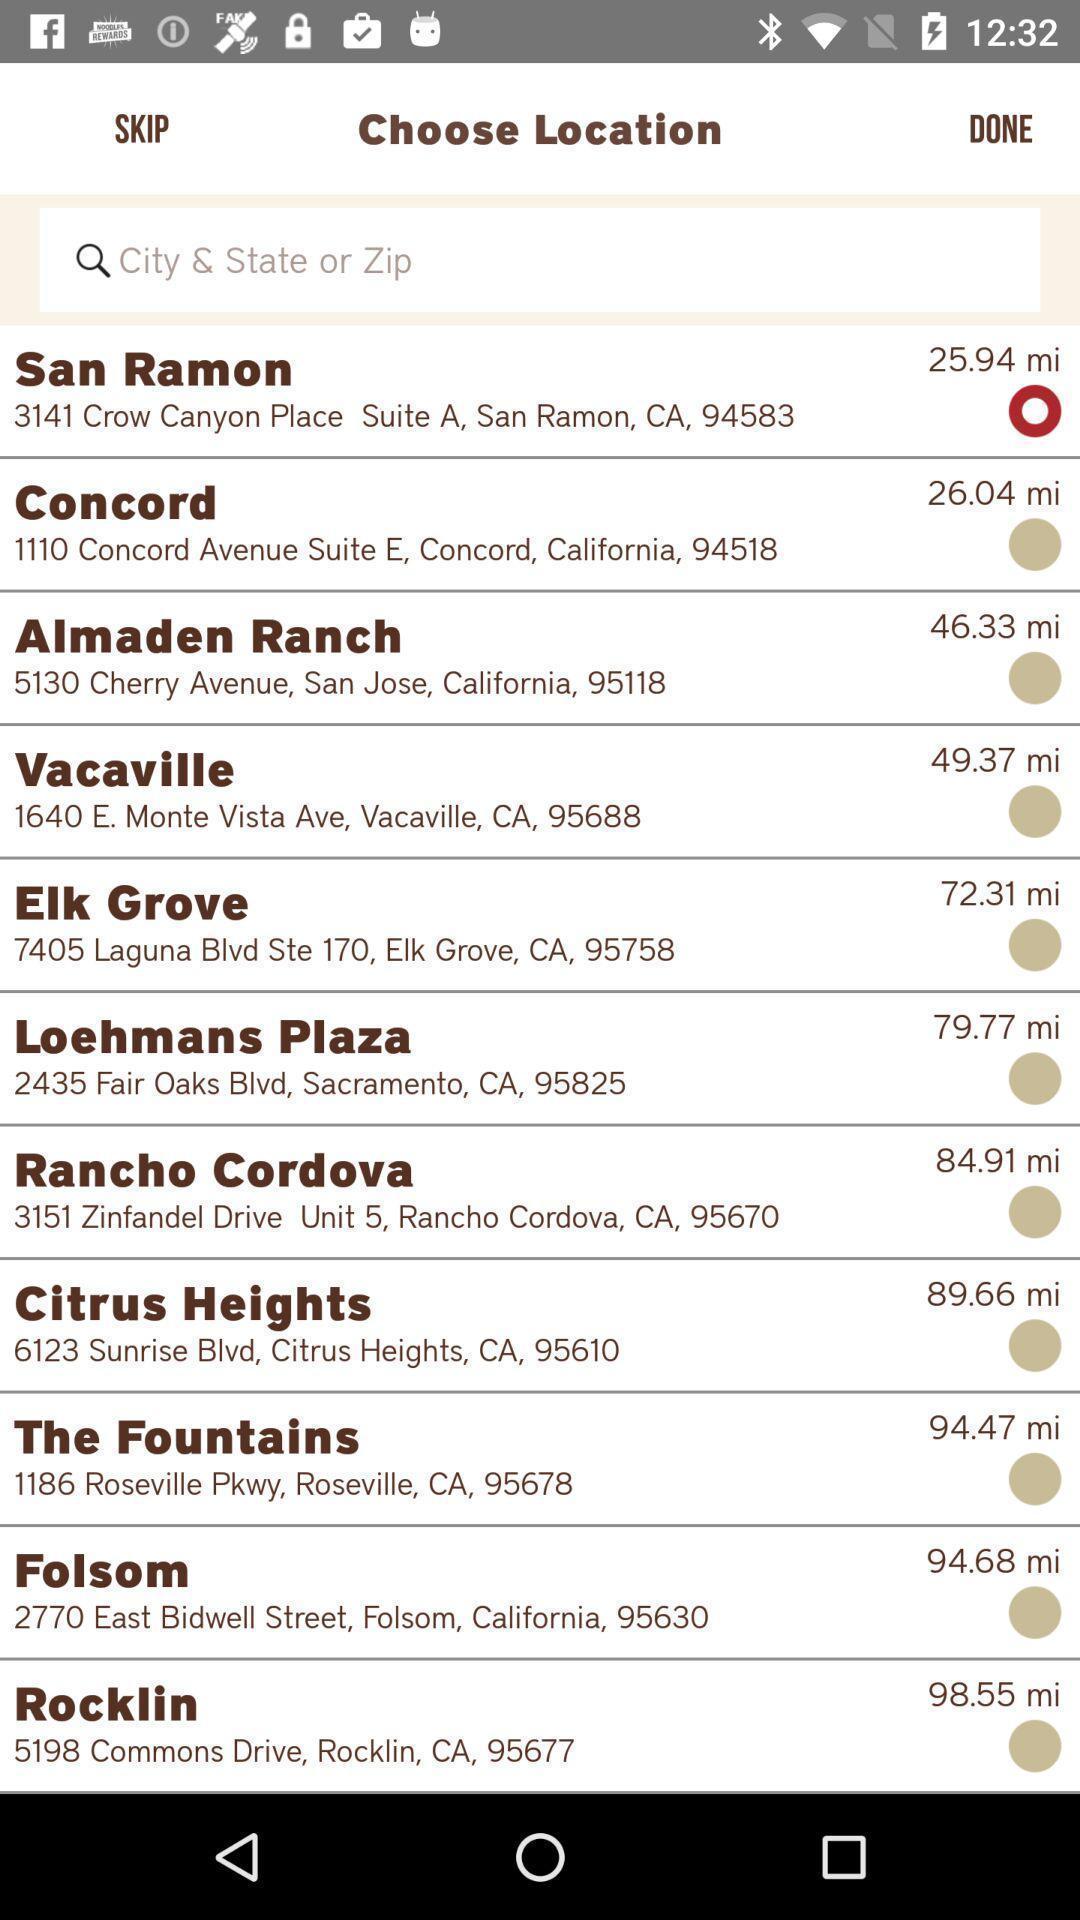Summarize the main components in this picture. Search bar to select for the location. 